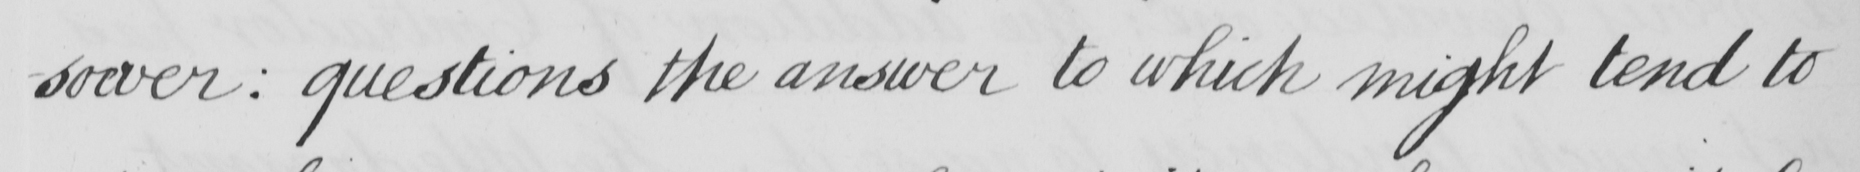Please transcribe the handwritten text in this image. -soever :  questions the answer to which might tend to 